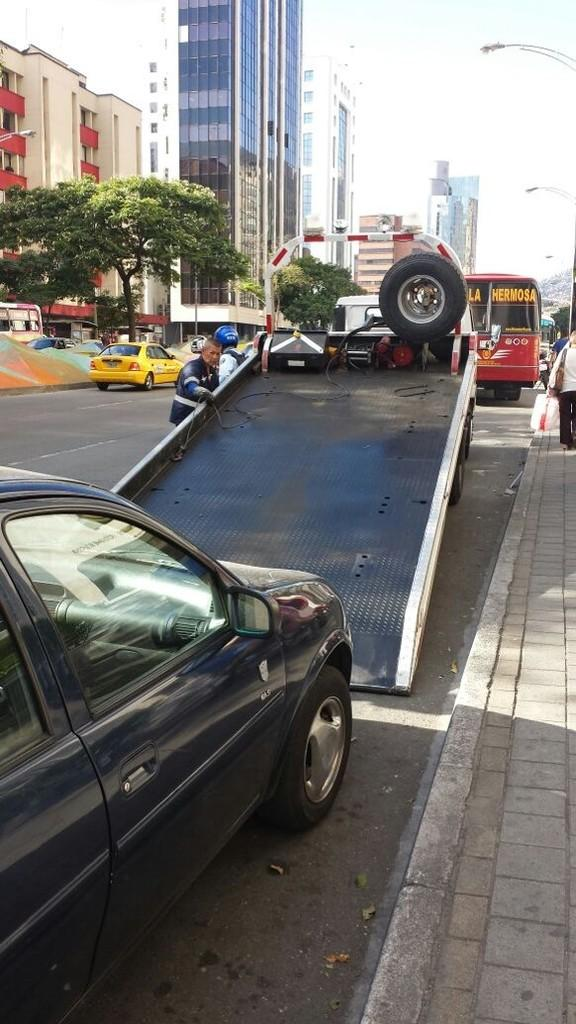What is happening to the car in the image? A car is being towed onto a truck in the image. What else can be seen on the road in the image? There are other vehicles on the road in the image. What is visible in the background of the image? There are buildings and trees in the background of the image. What type of skirt is the car wearing in the image? Cars do not wear skirts; the question is not applicable to the image. 